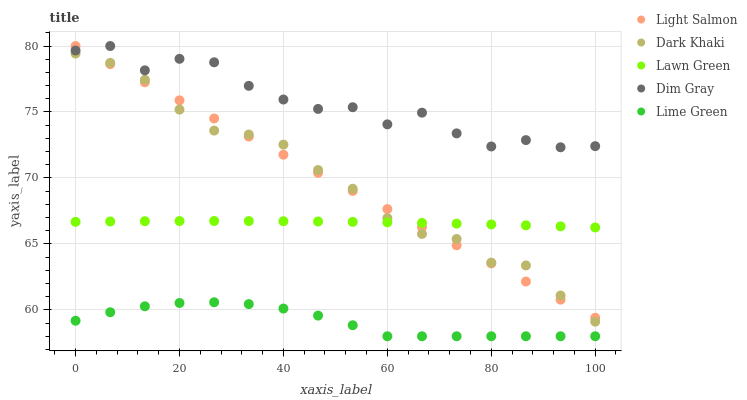Does Lime Green have the minimum area under the curve?
Answer yes or no. Yes. Does Dim Gray have the maximum area under the curve?
Answer yes or no. Yes. Does Lawn Green have the minimum area under the curve?
Answer yes or no. No. Does Lawn Green have the maximum area under the curve?
Answer yes or no. No. Is Light Salmon the smoothest?
Answer yes or no. Yes. Is Dim Gray the roughest?
Answer yes or no. Yes. Is Lawn Green the smoothest?
Answer yes or no. No. Is Lawn Green the roughest?
Answer yes or no. No. Does Lime Green have the lowest value?
Answer yes or no. Yes. Does Lawn Green have the lowest value?
Answer yes or no. No. Does Dim Gray have the highest value?
Answer yes or no. Yes. Does Lawn Green have the highest value?
Answer yes or no. No. Is Lime Green less than Lawn Green?
Answer yes or no. Yes. Is Dim Gray greater than Dark Khaki?
Answer yes or no. Yes. Does Dim Gray intersect Light Salmon?
Answer yes or no. Yes. Is Dim Gray less than Light Salmon?
Answer yes or no. No. Is Dim Gray greater than Light Salmon?
Answer yes or no. No. Does Lime Green intersect Lawn Green?
Answer yes or no. No. 